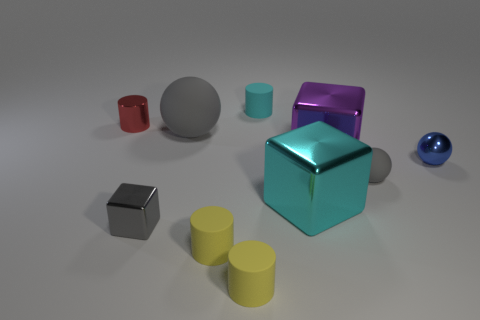Do the large rubber object and the small rubber sphere have the same color? yes 